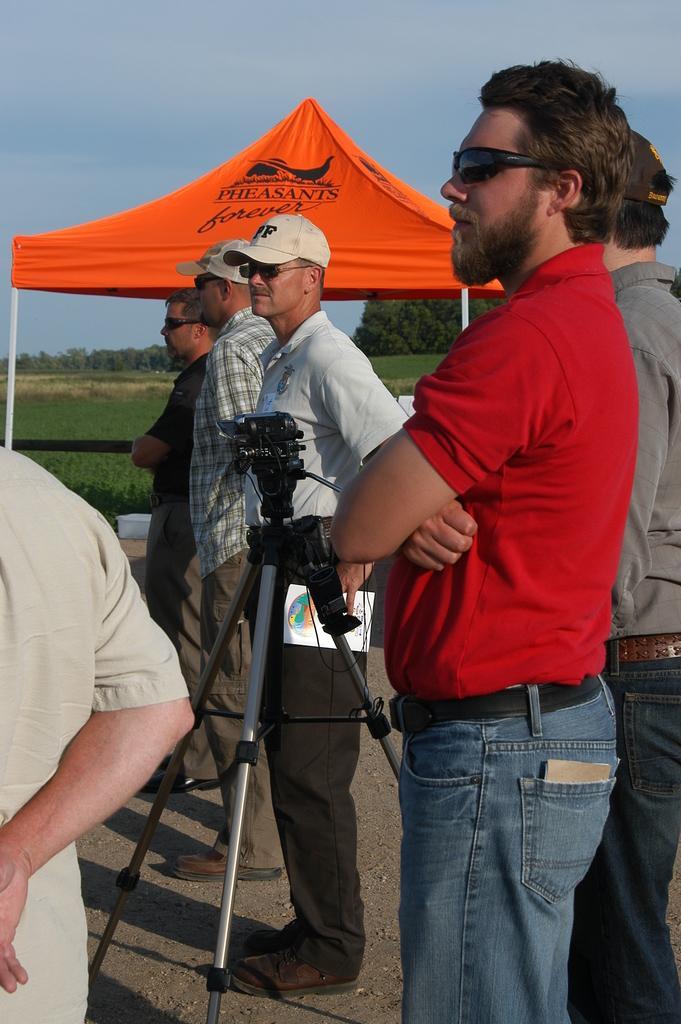Can you describe this image briefly? In this image there are few persons standing on the road. There is a camera with a stand. Trees and grass are also visible. Sky is at the top. 